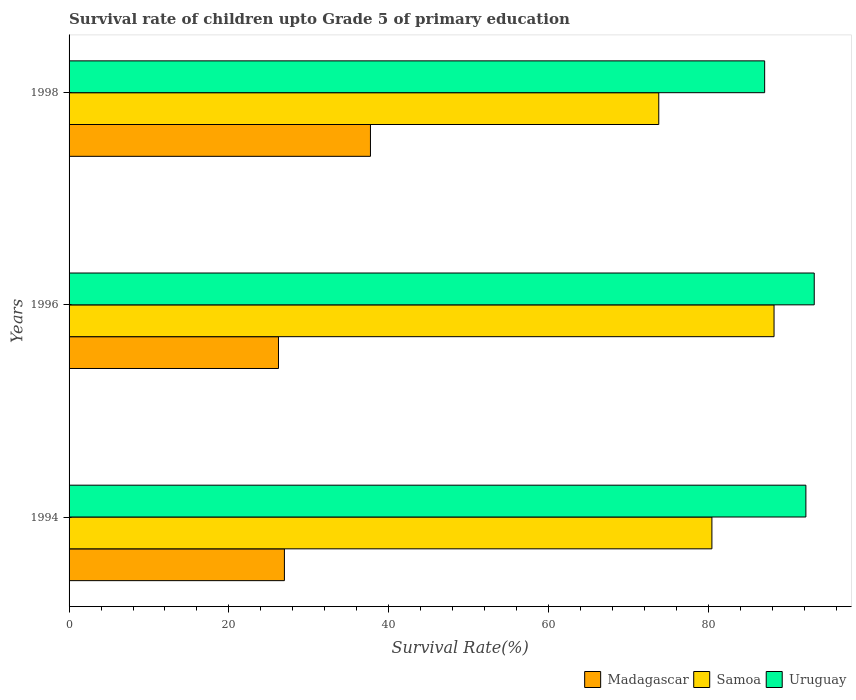How many bars are there on the 2nd tick from the top?
Your answer should be very brief. 3. What is the label of the 3rd group of bars from the top?
Provide a succinct answer. 1994. In how many cases, is the number of bars for a given year not equal to the number of legend labels?
Provide a short and direct response. 0. What is the survival rate of children in Samoa in 1994?
Make the answer very short. 80.45. Across all years, what is the maximum survival rate of children in Madagascar?
Your answer should be very brief. 37.72. Across all years, what is the minimum survival rate of children in Samoa?
Offer a terse response. 73.8. In which year was the survival rate of children in Madagascar maximum?
Offer a very short reply. 1998. What is the total survival rate of children in Uruguay in the graph?
Offer a very short reply. 272.53. What is the difference between the survival rate of children in Madagascar in 1994 and that in 1998?
Provide a succinct answer. -10.77. What is the difference between the survival rate of children in Samoa in 1994 and the survival rate of children in Madagascar in 1996?
Provide a short and direct response. 54.24. What is the average survival rate of children in Madagascar per year?
Provide a short and direct response. 30.29. In the year 1996, what is the difference between the survival rate of children in Uruguay and survival rate of children in Madagascar?
Your answer should be compact. 67.05. What is the ratio of the survival rate of children in Uruguay in 1994 to that in 1996?
Your answer should be very brief. 0.99. Is the survival rate of children in Samoa in 1994 less than that in 1996?
Your response must be concise. Yes. Is the difference between the survival rate of children in Uruguay in 1994 and 1998 greater than the difference between the survival rate of children in Madagascar in 1994 and 1998?
Keep it short and to the point. Yes. What is the difference between the highest and the second highest survival rate of children in Uruguay?
Provide a short and direct response. 1.04. What is the difference between the highest and the lowest survival rate of children in Madagascar?
Keep it short and to the point. 11.51. In how many years, is the survival rate of children in Samoa greater than the average survival rate of children in Samoa taken over all years?
Offer a very short reply. 1. Is the sum of the survival rate of children in Samoa in 1994 and 1996 greater than the maximum survival rate of children in Madagascar across all years?
Your answer should be compact. Yes. What does the 1st bar from the top in 1998 represents?
Your response must be concise. Uruguay. What does the 2nd bar from the bottom in 1996 represents?
Your answer should be compact. Samoa. Is it the case that in every year, the sum of the survival rate of children in Uruguay and survival rate of children in Samoa is greater than the survival rate of children in Madagascar?
Keep it short and to the point. Yes. How many bars are there?
Offer a terse response. 9. Are all the bars in the graph horizontal?
Offer a very short reply. Yes. How many years are there in the graph?
Your answer should be compact. 3. What is the difference between two consecutive major ticks on the X-axis?
Make the answer very short. 20. Are the values on the major ticks of X-axis written in scientific E-notation?
Offer a terse response. No. What is the title of the graph?
Offer a terse response. Survival rate of children upto Grade 5 of primary education. What is the label or title of the X-axis?
Keep it short and to the point. Survival Rate(%). What is the Survival Rate(%) of Madagascar in 1994?
Your answer should be very brief. 26.95. What is the Survival Rate(%) in Samoa in 1994?
Keep it short and to the point. 80.45. What is the Survival Rate(%) of Uruguay in 1994?
Provide a succinct answer. 92.21. What is the Survival Rate(%) of Madagascar in 1996?
Offer a terse response. 26.21. What is the Survival Rate(%) in Samoa in 1996?
Make the answer very short. 88.23. What is the Survival Rate(%) in Uruguay in 1996?
Offer a terse response. 93.26. What is the Survival Rate(%) of Madagascar in 1998?
Give a very brief answer. 37.72. What is the Survival Rate(%) in Samoa in 1998?
Make the answer very short. 73.8. What is the Survival Rate(%) of Uruguay in 1998?
Give a very brief answer. 87.05. Across all years, what is the maximum Survival Rate(%) in Madagascar?
Give a very brief answer. 37.72. Across all years, what is the maximum Survival Rate(%) of Samoa?
Offer a terse response. 88.23. Across all years, what is the maximum Survival Rate(%) in Uruguay?
Your response must be concise. 93.26. Across all years, what is the minimum Survival Rate(%) in Madagascar?
Offer a very short reply. 26.21. Across all years, what is the minimum Survival Rate(%) of Samoa?
Provide a succinct answer. 73.8. Across all years, what is the minimum Survival Rate(%) in Uruguay?
Your answer should be very brief. 87.05. What is the total Survival Rate(%) in Madagascar in the graph?
Make the answer very short. 90.88. What is the total Survival Rate(%) of Samoa in the graph?
Your answer should be very brief. 242.48. What is the total Survival Rate(%) in Uruguay in the graph?
Your answer should be very brief. 272.53. What is the difference between the Survival Rate(%) in Madagascar in 1994 and that in 1996?
Give a very brief answer. 0.74. What is the difference between the Survival Rate(%) of Samoa in 1994 and that in 1996?
Make the answer very short. -7.78. What is the difference between the Survival Rate(%) in Uruguay in 1994 and that in 1996?
Your answer should be very brief. -1.04. What is the difference between the Survival Rate(%) in Madagascar in 1994 and that in 1998?
Your answer should be compact. -10.77. What is the difference between the Survival Rate(%) of Samoa in 1994 and that in 1998?
Provide a succinct answer. 6.65. What is the difference between the Survival Rate(%) of Uruguay in 1994 and that in 1998?
Give a very brief answer. 5.16. What is the difference between the Survival Rate(%) in Madagascar in 1996 and that in 1998?
Keep it short and to the point. -11.51. What is the difference between the Survival Rate(%) of Samoa in 1996 and that in 1998?
Your answer should be very brief. 14.43. What is the difference between the Survival Rate(%) of Uruguay in 1996 and that in 1998?
Give a very brief answer. 6.2. What is the difference between the Survival Rate(%) of Madagascar in 1994 and the Survival Rate(%) of Samoa in 1996?
Your answer should be very brief. -61.28. What is the difference between the Survival Rate(%) in Madagascar in 1994 and the Survival Rate(%) in Uruguay in 1996?
Provide a short and direct response. -66.31. What is the difference between the Survival Rate(%) in Samoa in 1994 and the Survival Rate(%) in Uruguay in 1996?
Keep it short and to the point. -12.81. What is the difference between the Survival Rate(%) of Madagascar in 1994 and the Survival Rate(%) of Samoa in 1998?
Offer a very short reply. -46.85. What is the difference between the Survival Rate(%) in Madagascar in 1994 and the Survival Rate(%) in Uruguay in 1998?
Keep it short and to the point. -60.1. What is the difference between the Survival Rate(%) in Samoa in 1994 and the Survival Rate(%) in Uruguay in 1998?
Provide a short and direct response. -6.6. What is the difference between the Survival Rate(%) of Madagascar in 1996 and the Survival Rate(%) of Samoa in 1998?
Your answer should be very brief. -47.59. What is the difference between the Survival Rate(%) in Madagascar in 1996 and the Survival Rate(%) in Uruguay in 1998?
Your answer should be compact. -60.85. What is the difference between the Survival Rate(%) of Samoa in 1996 and the Survival Rate(%) of Uruguay in 1998?
Your response must be concise. 1.17. What is the average Survival Rate(%) of Madagascar per year?
Make the answer very short. 30.29. What is the average Survival Rate(%) of Samoa per year?
Offer a terse response. 80.83. What is the average Survival Rate(%) in Uruguay per year?
Offer a very short reply. 90.84. In the year 1994, what is the difference between the Survival Rate(%) of Madagascar and Survival Rate(%) of Samoa?
Keep it short and to the point. -53.5. In the year 1994, what is the difference between the Survival Rate(%) in Madagascar and Survival Rate(%) in Uruguay?
Offer a terse response. -65.26. In the year 1994, what is the difference between the Survival Rate(%) of Samoa and Survival Rate(%) of Uruguay?
Keep it short and to the point. -11.76. In the year 1996, what is the difference between the Survival Rate(%) of Madagascar and Survival Rate(%) of Samoa?
Ensure brevity in your answer.  -62.02. In the year 1996, what is the difference between the Survival Rate(%) in Madagascar and Survival Rate(%) in Uruguay?
Offer a terse response. -67.05. In the year 1996, what is the difference between the Survival Rate(%) of Samoa and Survival Rate(%) of Uruguay?
Ensure brevity in your answer.  -5.03. In the year 1998, what is the difference between the Survival Rate(%) in Madagascar and Survival Rate(%) in Samoa?
Ensure brevity in your answer.  -36.08. In the year 1998, what is the difference between the Survival Rate(%) in Madagascar and Survival Rate(%) in Uruguay?
Keep it short and to the point. -49.34. In the year 1998, what is the difference between the Survival Rate(%) of Samoa and Survival Rate(%) of Uruguay?
Your response must be concise. -13.25. What is the ratio of the Survival Rate(%) in Madagascar in 1994 to that in 1996?
Your answer should be compact. 1.03. What is the ratio of the Survival Rate(%) of Samoa in 1994 to that in 1996?
Make the answer very short. 0.91. What is the ratio of the Survival Rate(%) in Uruguay in 1994 to that in 1996?
Offer a terse response. 0.99. What is the ratio of the Survival Rate(%) of Madagascar in 1994 to that in 1998?
Provide a succinct answer. 0.71. What is the ratio of the Survival Rate(%) of Samoa in 1994 to that in 1998?
Ensure brevity in your answer.  1.09. What is the ratio of the Survival Rate(%) in Uruguay in 1994 to that in 1998?
Offer a terse response. 1.06. What is the ratio of the Survival Rate(%) of Madagascar in 1996 to that in 1998?
Make the answer very short. 0.69. What is the ratio of the Survival Rate(%) in Samoa in 1996 to that in 1998?
Your response must be concise. 1.2. What is the ratio of the Survival Rate(%) of Uruguay in 1996 to that in 1998?
Provide a succinct answer. 1.07. What is the difference between the highest and the second highest Survival Rate(%) of Madagascar?
Ensure brevity in your answer.  10.77. What is the difference between the highest and the second highest Survival Rate(%) in Samoa?
Offer a very short reply. 7.78. What is the difference between the highest and the second highest Survival Rate(%) in Uruguay?
Offer a terse response. 1.04. What is the difference between the highest and the lowest Survival Rate(%) of Madagascar?
Your response must be concise. 11.51. What is the difference between the highest and the lowest Survival Rate(%) in Samoa?
Offer a terse response. 14.43. What is the difference between the highest and the lowest Survival Rate(%) in Uruguay?
Ensure brevity in your answer.  6.2. 